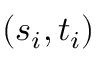Convert formula to latex. <formula><loc_0><loc_0><loc_500><loc_500>( s _ { i } , t _ { i } )</formula> 